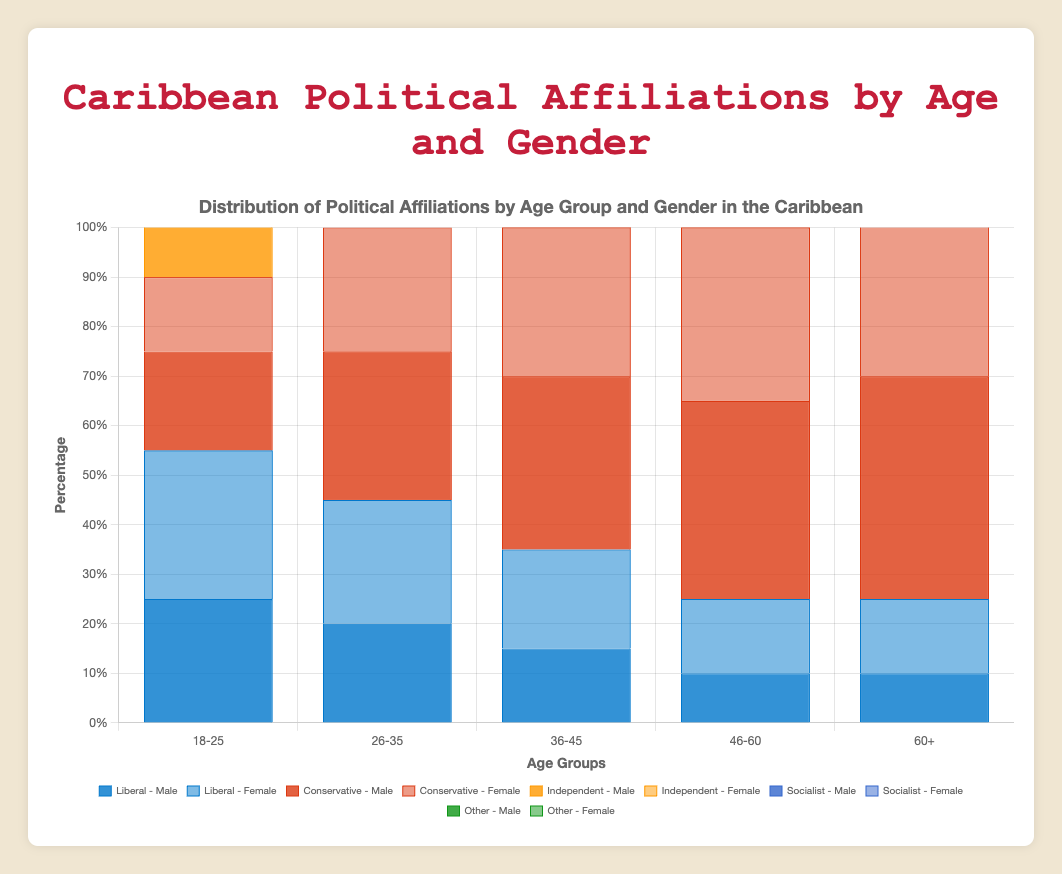What is the most common political affiliation for males aged 46-60? For males aged 46-60, the highest bar is for Conservative affiliation.
Answer: Conservative How do the percentage of Liberal females compare across all age groups? To compare, look at the height of the Liberal - Female bars across all age groups. For 18-25, 30%; for 26-35, 25%; for 36-45, 20%; for 46-60, 15%; for 60+, 15%.
Answer: Decreases with age Which age group has the highest percentage of Independent males? Look for the tallest Independent - Male bar among all age groups. The highest percentage is for the 36-45 group at 25%.
Answer: 36-45 Are there more Liberal or Conservative females in the 18-25 age group? Compare the bars: Liberal - Female (30%) is higher than Conservative - Female (15%).
Answer: Liberal Which gender has a higher percentage of Socialist affiliation in the age group 26-35? Compare the Socialist bars for males and females aged 26-35. Males have 15% and females have 10%.
Answer: Male What is the total percentage of Liberal and Socialist affiliations for females aged 60+? Add the percentages of Liberal (15%) and Socialist (10%) for females aged 60+. 15 + 10 = 25.
Answer: 25% Which age group shows the least percentage of Other affiliations, irrespective of gender? The smallest Other bar for any age group is 5%, seen in both 18-25 and 26-35 age groups.
Answer: 18-25 and 26-35 What is the difference in the percentage of Conservatives between males aged 46-60 and males aged 60+? For males aged 46-60, Conservative is 40%. For 60+, Conservative is 45%. The difference is 45 - 40 = 5.
Answer: 5% How does the percentage of Conservative males change from age 18-25 to 46-60? Track the height of the Conservative - Male bars across these ages: 18-25 (20%), 26-35 (30%), 36-45 (35%), and 46-60 (40%).
Answer: Increases with age Compare the percentage of Independents between males and females aged 36-45. Look at the Independent bars for 36-45: Males have 25%, and females have 25%. They are equal.
Answer: Equal 